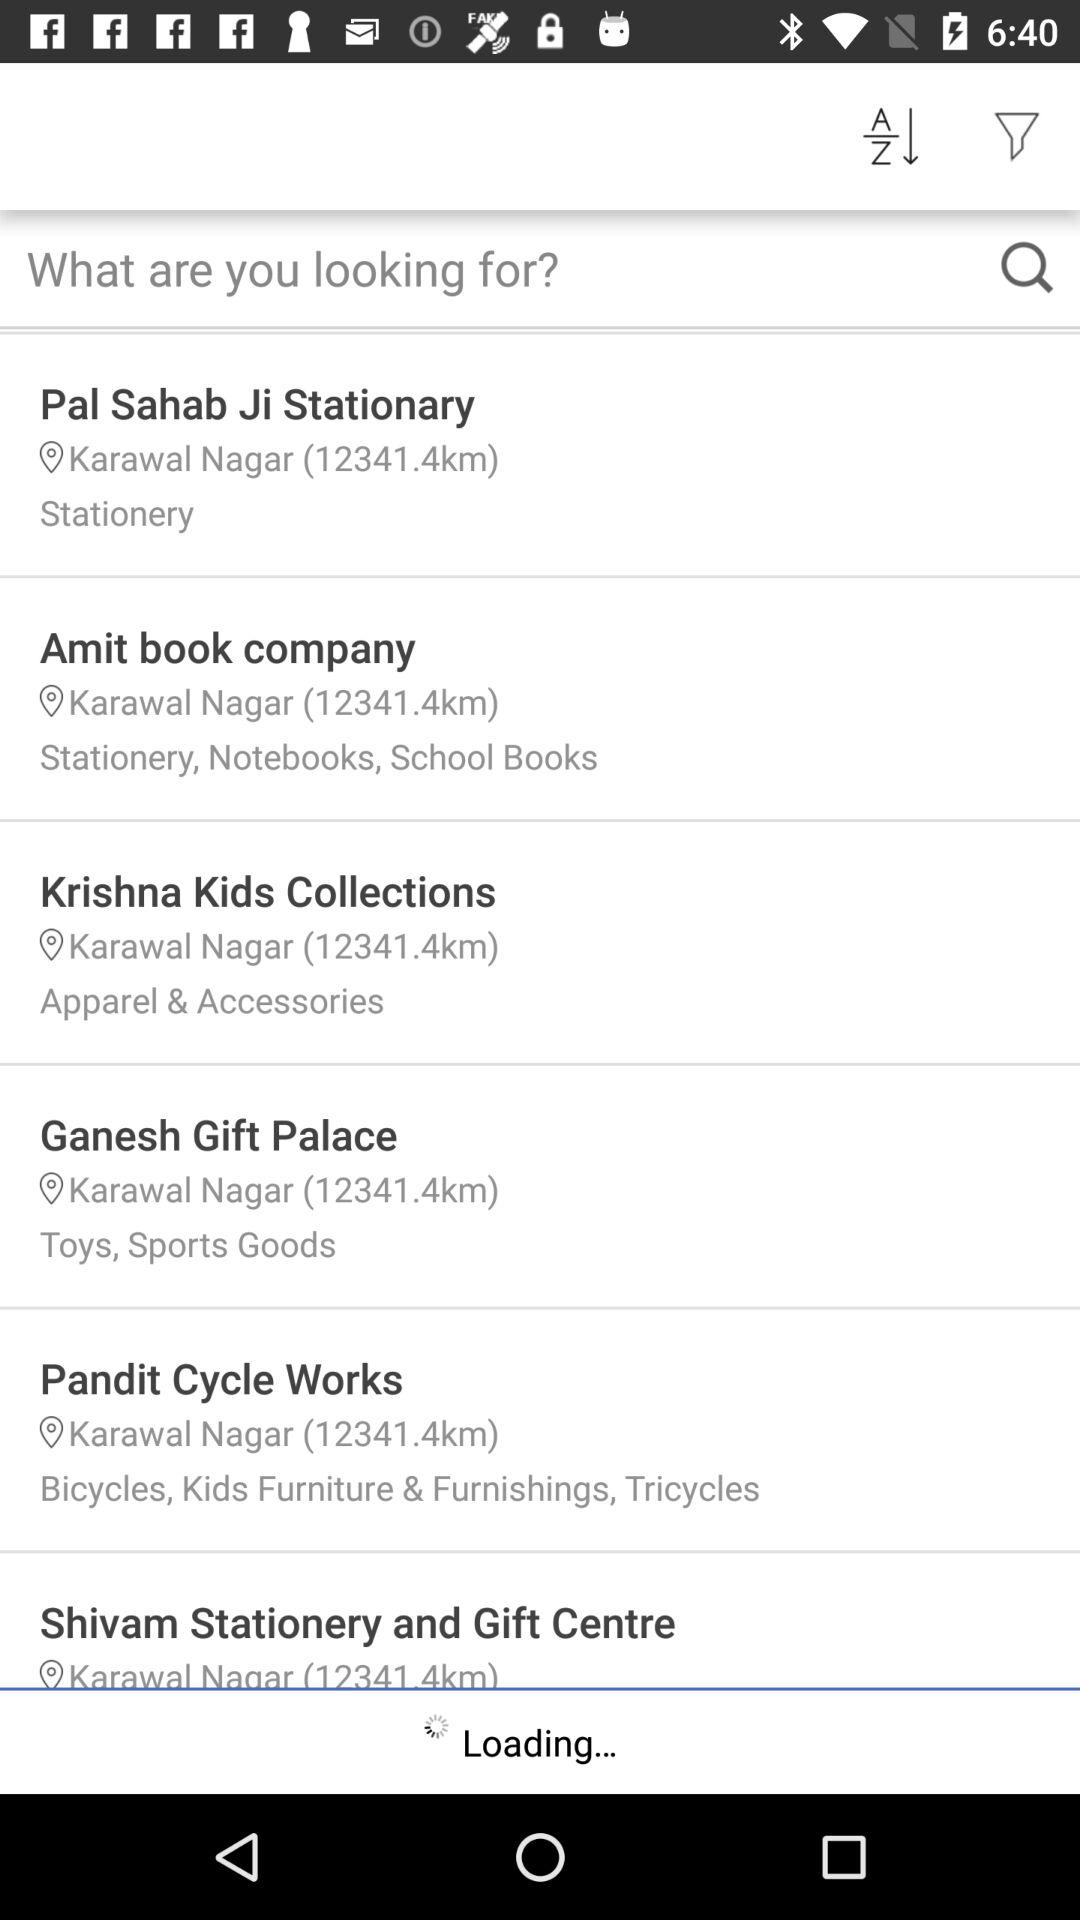What type of shop is "Ganesh Gift Palace"? "Ganesh Gift Palace" is a toy and sporting goods shop. 